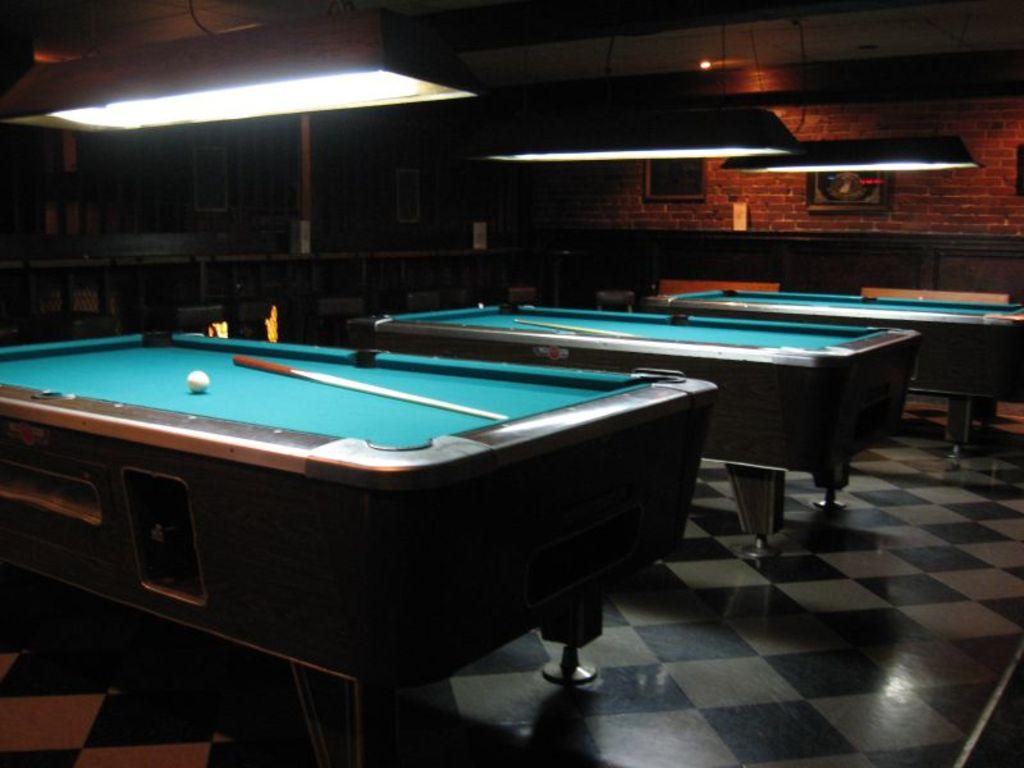What type of light can be seen in the image? There is a light in the image. What piece of furniture is present in the image? There is a table in the image. What objects are on the table? A ball and stick are present on the table. What part of the room is visible in the image? The floor is visible in the image. What type of wall material is present in the image? There is a wall made of bricks in the image. What decorative items are on the wall? Photo frames are present on the wall. What type of skirt is hanging from the light in the image? There is no skirt present in the image; only a light, table, ball, stick, floor, brick wall, and photo frames are visible. How many trees can be seen in the image? There are no trees present in the image. 